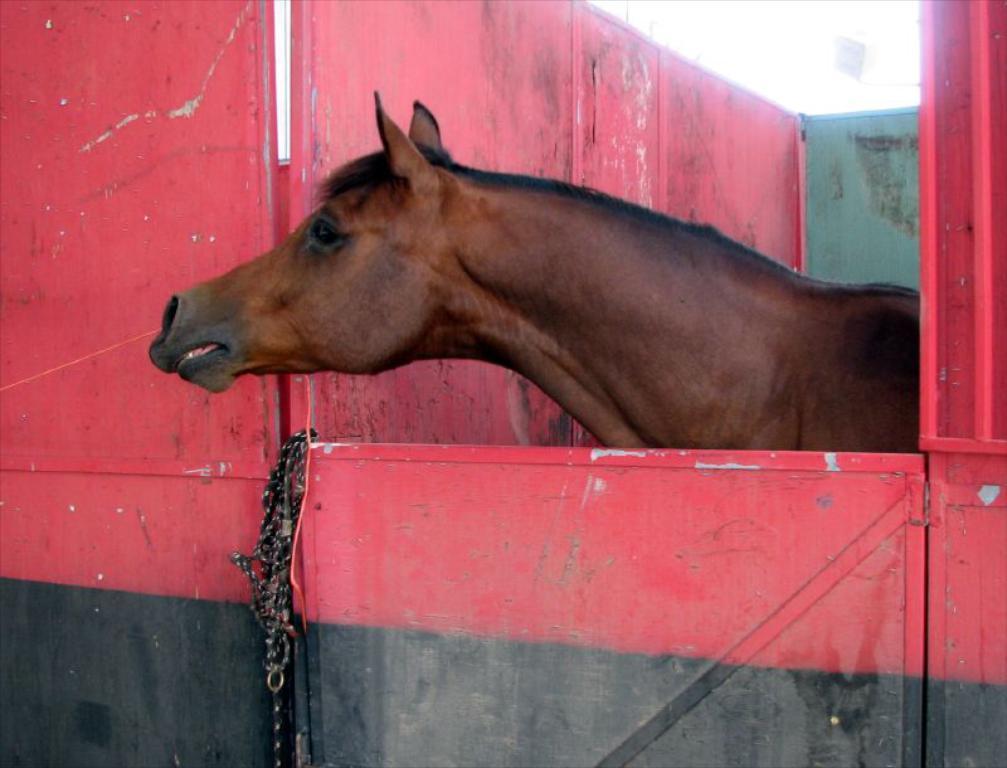Can you describe this image briefly? This picture shows a horse in the stable, We see a door with a chain. It is brown in color. 